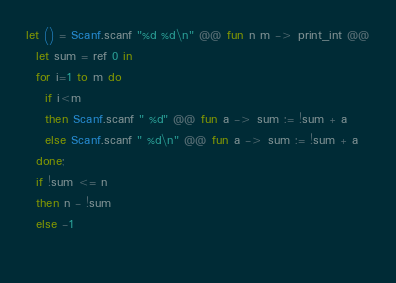Convert code to text. <code><loc_0><loc_0><loc_500><loc_500><_OCaml_>let () = Scanf.scanf "%d %d\n" @@ fun n m -> print_int @@
  let sum = ref 0 in
  for i=1 to m do
    if i<m 
    then Scanf.scanf " %d" @@ fun a -> sum := !sum + a
    else Scanf.scanf " %d\n" @@ fun a -> sum := !sum + a
  done;
  if !sum <= n
  then n - !sum
  else -1
    </code> 